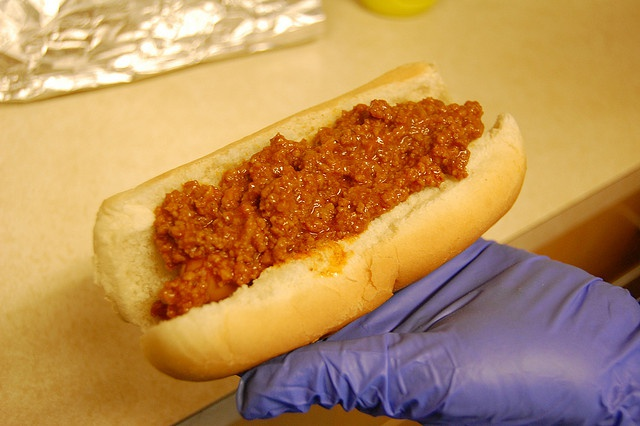Describe the objects in this image and their specific colors. I can see hot dog in tan, red, orange, and brown tones and people in tan, purple, and gray tones in this image. 